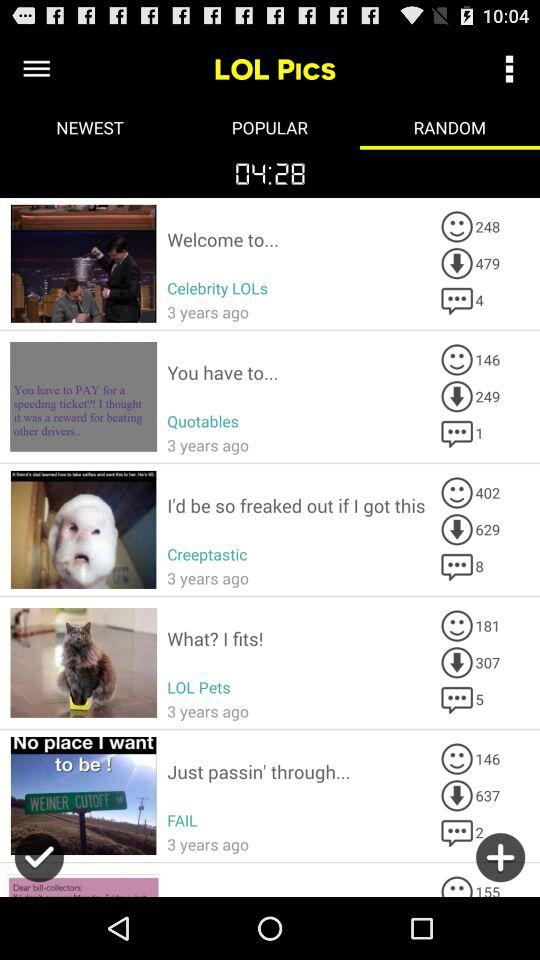How many people have downloaded the "Celebrity LOLs"? The number of people who have downloaded the "Celebrity LOLs" is 479. 